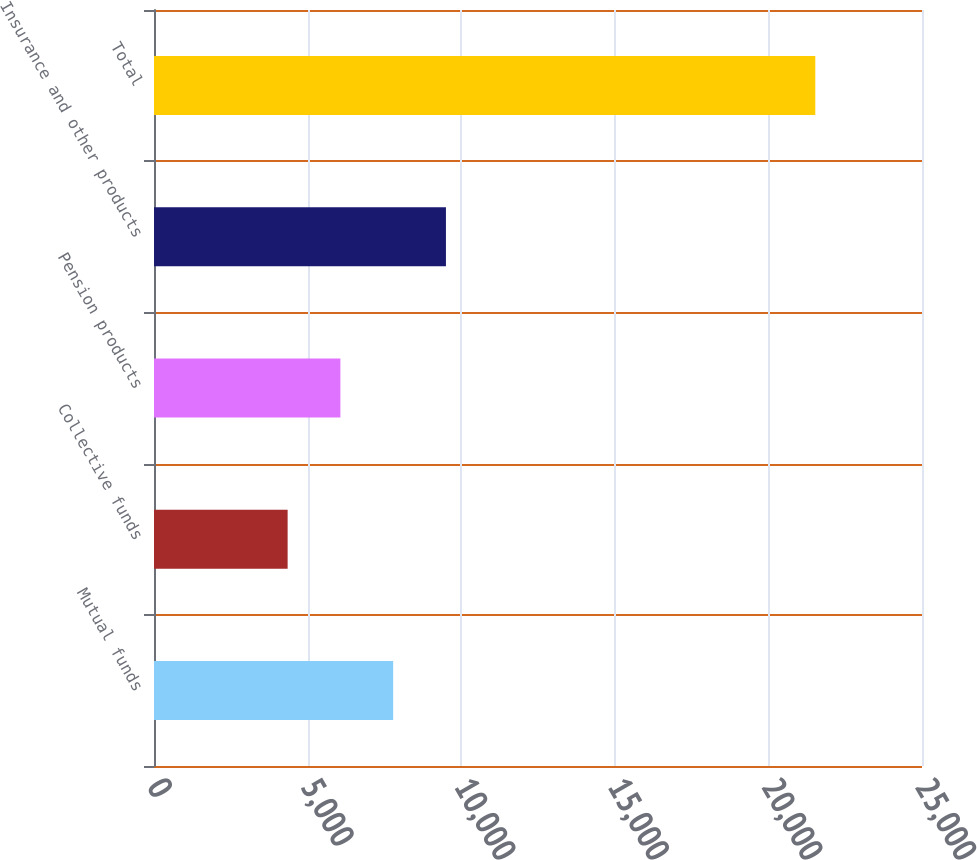<chart> <loc_0><loc_0><loc_500><loc_500><bar_chart><fcel>Mutual funds<fcel>Collective funds<fcel>Pension products<fcel>Insurance and other products<fcel>Total<nl><fcel>7785.4<fcel>4350<fcel>6067.7<fcel>9503.1<fcel>21527<nl></chart> 